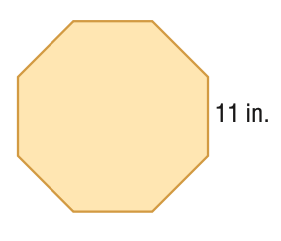Answer the mathemtical geometry problem and directly provide the correct option letter.
Question: Find the area of the regular polygon. Round to the nearest tenth.
Choices: A: 73.0 B: 292.1 C: 584.2 D: 1168.5 C 